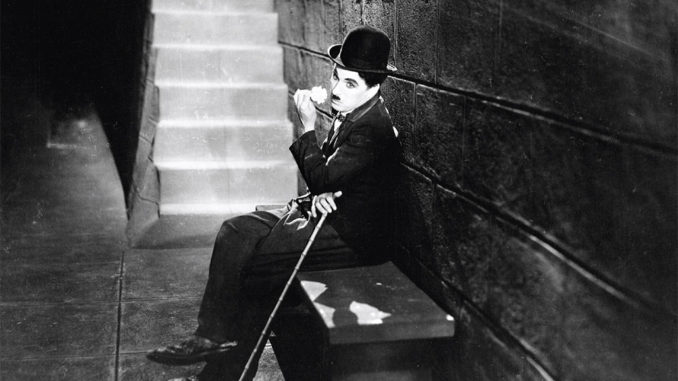Imagine a whimsical scenario where Chaplin’s character meets a time traveler. What happens next? In a twist of fate, the tranquil moment of reflection is interrupted by a shimmering portal that materializes beside the stone bench. Out steps a bewildered time traveler, garbed in futuristic attire with gadgets gleaming and beeping.*

TRAMP (startled, tipping his hat): "Well, I’ll be!"

TIME TRAVELER: "Excuse me, but can you tell me where—or rather when—I am?"

The Tramp bounces to his feet, curious and cautious, twirling his cane in thought. Suddenly, with an impish grin, he points out the time traveler’s mismatched footwear—one sock too long, one shoe too large.*

TIME TRAVELER (sheepish): "Oh dear, I suppose adjusting to this era has its oddities."

TRAMP: (with a mischievous twinkle) "Come along, we've much to explore—your era and mine,friend!"

And so, the unlikely pair set off down the cobblestone path, embarking on an adventure where past and future learn to dance harmoniously in the present. 